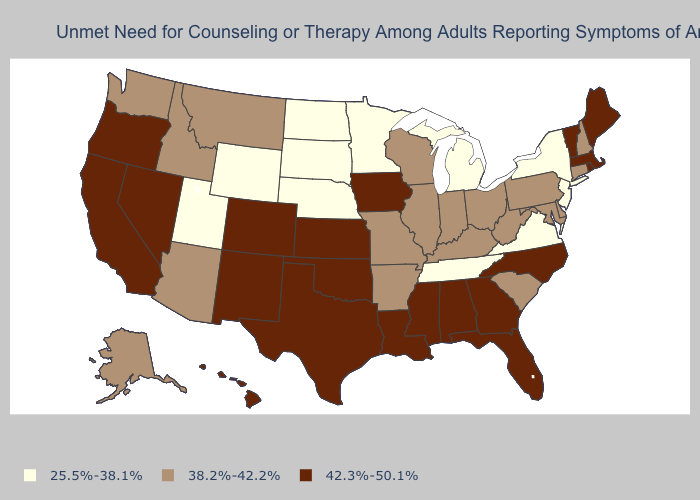Does New Hampshire have the highest value in the Northeast?
Give a very brief answer. No. Does the first symbol in the legend represent the smallest category?
Give a very brief answer. Yes. Which states have the highest value in the USA?
Keep it brief. Alabama, California, Colorado, Florida, Georgia, Hawaii, Iowa, Kansas, Louisiana, Maine, Massachusetts, Mississippi, Nevada, New Mexico, North Carolina, Oklahoma, Oregon, Rhode Island, Texas, Vermont. Which states have the highest value in the USA?
Be succinct. Alabama, California, Colorado, Florida, Georgia, Hawaii, Iowa, Kansas, Louisiana, Maine, Massachusetts, Mississippi, Nevada, New Mexico, North Carolina, Oklahoma, Oregon, Rhode Island, Texas, Vermont. What is the value of South Dakota?
Write a very short answer. 25.5%-38.1%. Name the states that have a value in the range 25.5%-38.1%?
Keep it brief. Michigan, Minnesota, Nebraska, New Jersey, New York, North Dakota, South Dakota, Tennessee, Utah, Virginia, Wyoming. Does Louisiana have the lowest value in the USA?
Write a very short answer. No. Name the states that have a value in the range 25.5%-38.1%?
Be succinct. Michigan, Minnesota, Nebraska, New Jersey, New York, North Dakota, South Dakota, Tennessee, Utah, Virginia, Wyoming. Is the legend a continuous bar?
Quick response, please. No. What is the value of North Dakota?
Keep it brief. 25.5%-38.1%. Name the states that have a value in the range 38.2%-42.2%?
Short answer required. Alaska, Arizona, Arkansas, Connecticut, Delaware, Idaho, Illinois, Indiana, Kentucky, Maryland, Missouri, Montana, New Hampshire, Ohio, Pennsylvania, South Carolina, Washington, West Virginia, Wisconsin. Which states have the lowest value in the USA?
Quick response, please. Michigan, Minnesota, Nebraska, New Jersey, New York, North Dakota, South Dakota, Tennessee, Utah, Virginia, Wyoming. Name the states that have a value in the range 38.2%-42.2%?
Be succinct. Alaska, Arizona, Arkansas, Connecticut, Delaware, Idaho, Illinois, Indiana, Kentucky, Maryland, Missouri, Montana, New Hampshire, Ohio, Pennsylvania, South Carolina, Washington, West Virginia, Wisconsin. Name the states that have a value in the range 42.3%-50.1%?
Write a very short answer. Alabama, California, Colorado, Florida, Georgia, Hawaii, Iowa, Kansas, Louisiana, Maine, Massachusetts, Mississippi, Nevada, New Mexico, North Carolina, Oklahoma, Oregon, Rhode Island, Texas, Vermont. Which states hav the highest value in the West?
Write a very short answer. California, Colorado, Hawaii, Nevada, New Mexico, Oregon. 